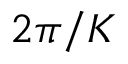<formula> <loc_0><loc_0><loc_500><loc_500>2 \pi / K</formula> 